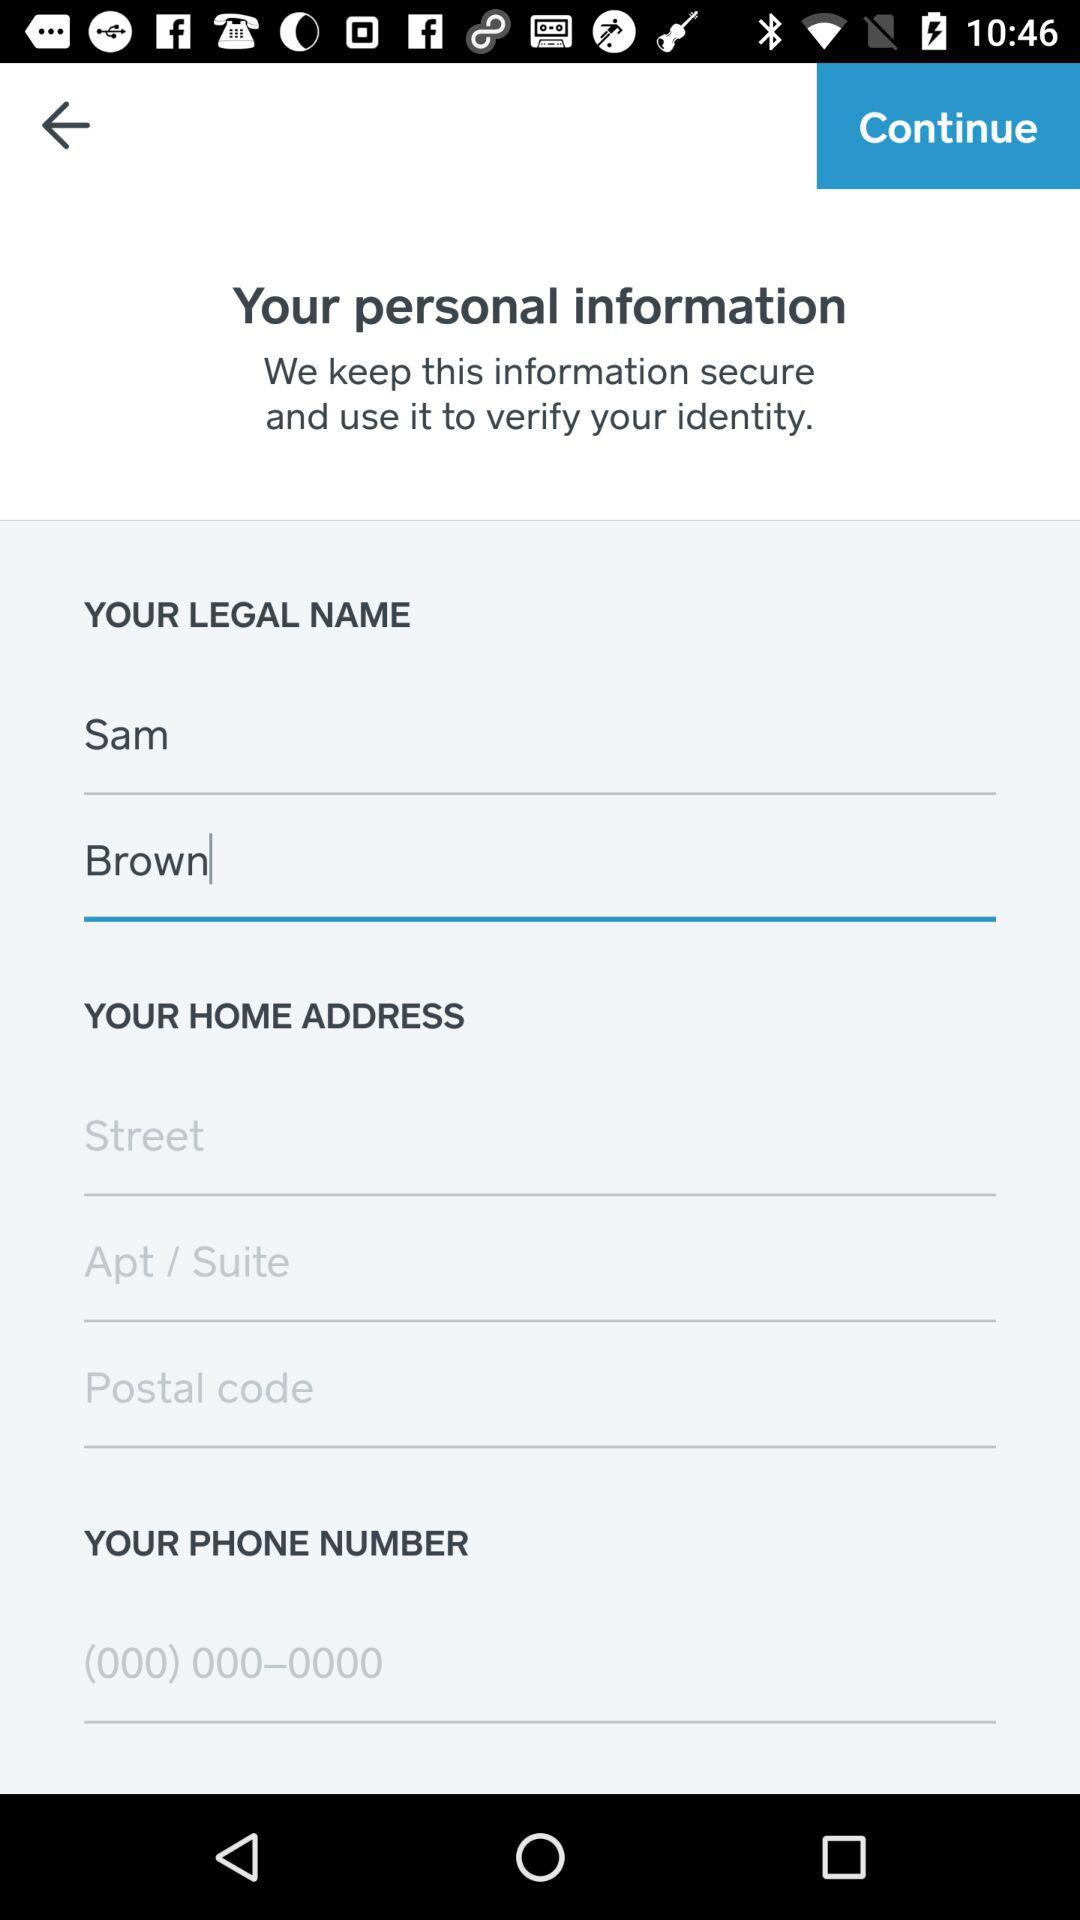What is the name? The name is Sam Brown. 